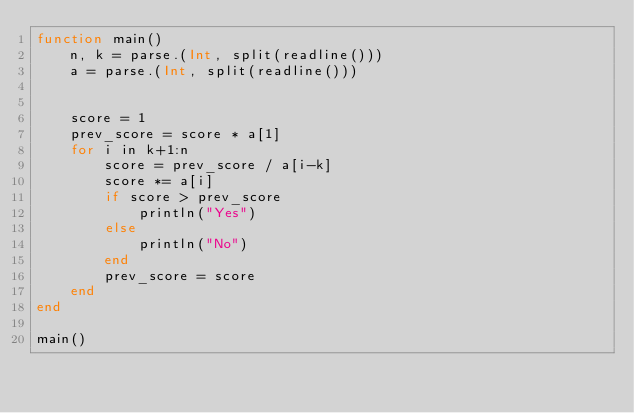Convert code to text. <code><loc_0><loc_0><loc_500><loc_500><_Julia_>function main()
    n, k = parse.(Int, split(readline()))
    a = parse.(Int, split(readline()))


    score = 1
    prev_score = score * a[1]
    for i in k+1:n
        score = prev_score / a[i-k] 
        score *= a[i]
        if score > prev_score
            println("Yes")
        else
            println("No")
        end
        prev_score = score
    end
end

main()</code> 